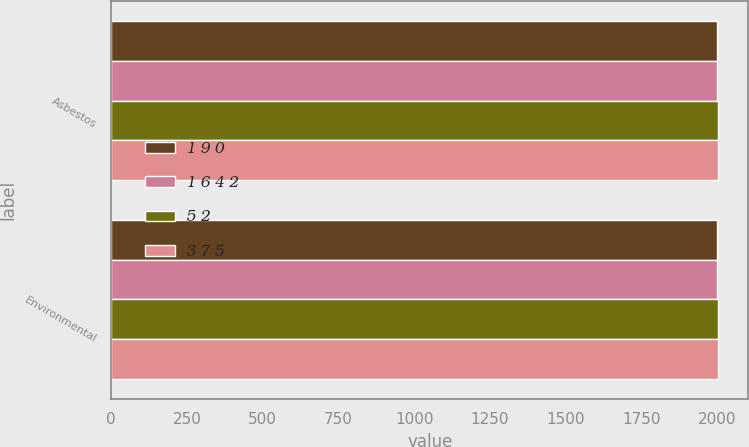Convert chart. <chart><loc_0><loc_0><loc_500><loc_500><stacked_bar_chart><ecel><fcel>Asbestos<fcel>Environmental<nl><fcel>1 9 0<fcel>2000<fcel>2000<nl><fcel>1 6 4 2<fcel>2001<fcel>2001<nl><fcel>5 2<fcel>2002<fcel>2002<nl><fcel>3 7 5<fcel>2003<fcel>2003<nl></chart> 